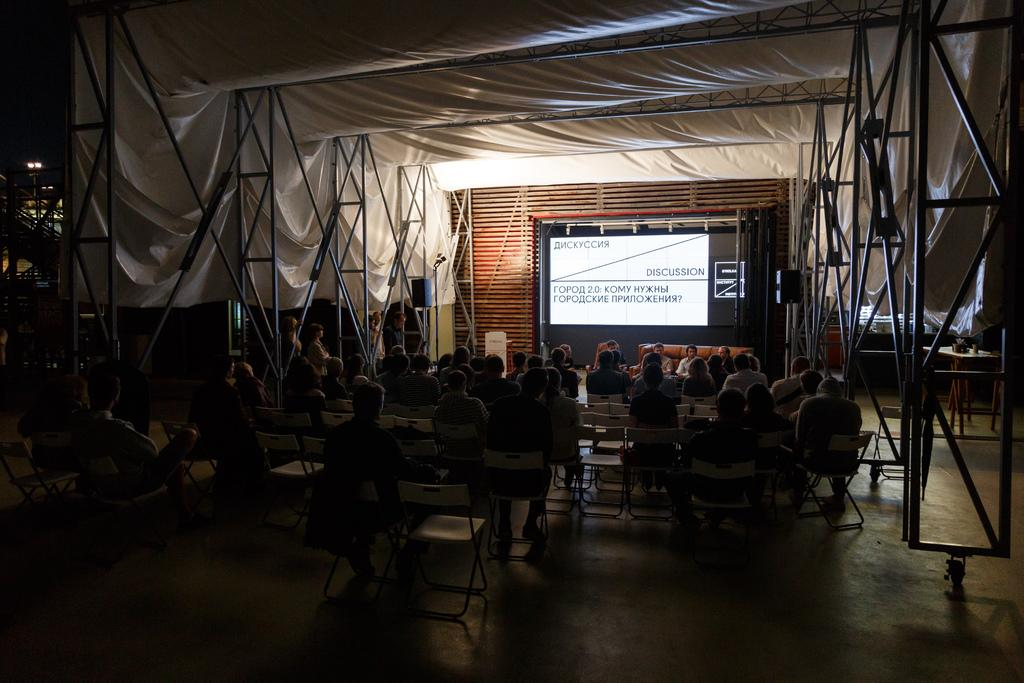What are the people in the image doing? The people in the image are sitting on chairs. What can be seen on the screen in the image? The facts do not specify what is on the screen. What is the sheet used for in the image? The facts do not specify the purpose of the sheet in the image. What is the source of light in the background of the image? The facts do not specify the source of light in the background. What type of furniture is being pulled by the horse-drawn carriage in the image? There is no horse-drawn carriage present in the image. 